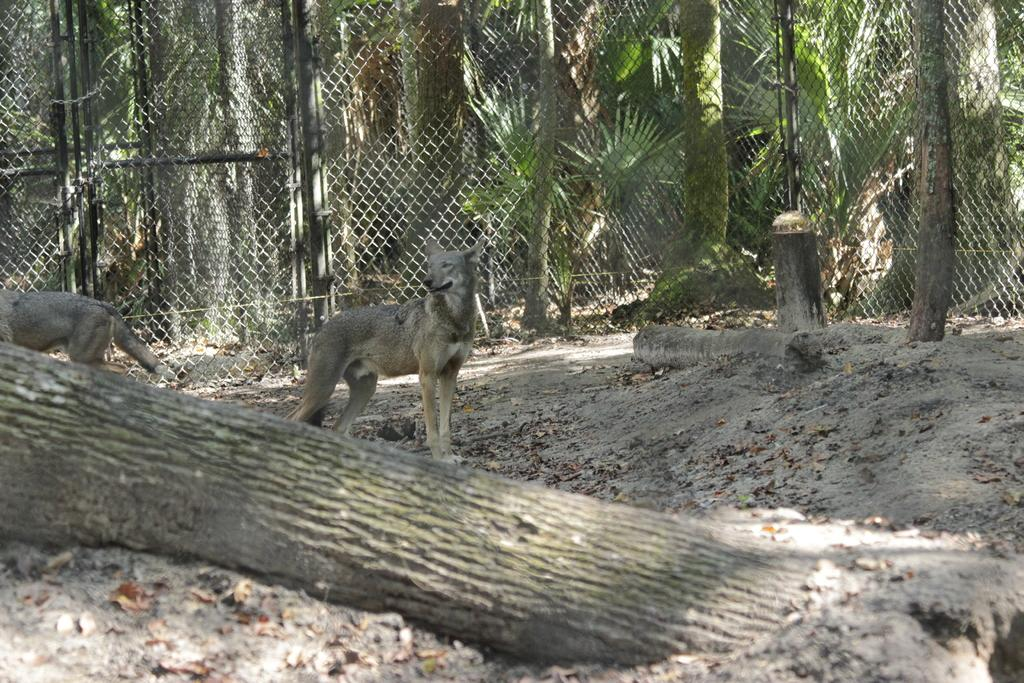What type of animals can be seen on the ground in the image? There are animals on the ground in the image, but their specific type is not mentioned in the facts. What is located near the animals on the ground? There is a tree trunk in the image. What can be seen in the distance behind the animals and tree trunk? There are trees visible in the background of the image. What architectural feature is present in the background of the image? There is a fence in the background of the image. What is the story behind the protest depicted in the image? There is no protest present in the image; it features animals on the ground, a tree trunk, trees in the background, and a fence. 